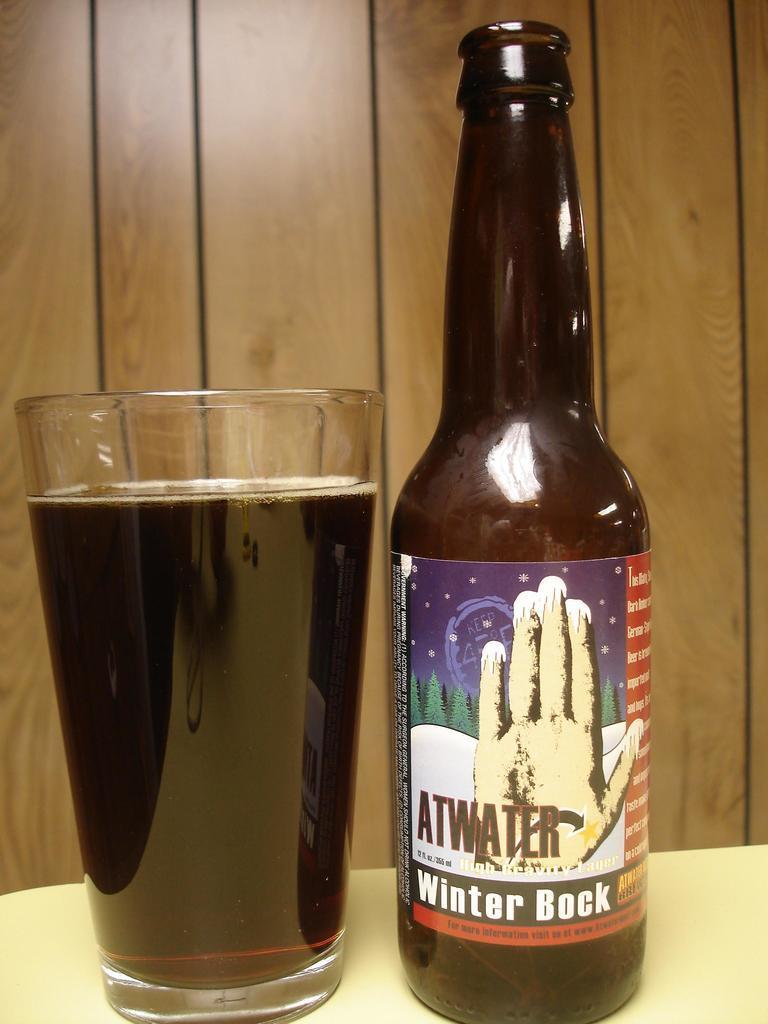How would you summarize this image in a sentence or two? In the foreground of this image, there is a glass with drink and a bottle placed beside it on a table. In the background, there is a wooden wall. 